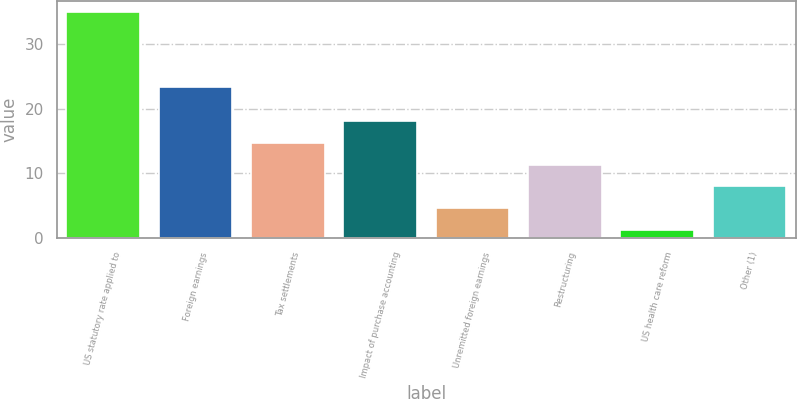Convert chart to OTSL. <chart><loc_0><loc_0><loc_500><loc_500><bar_chart><fcel>US statutory rate applied to<fcel>Foreign earnings<fcel>Tax settlements<fcel>Impact of purchase accounting<fcel>Unremitted foreign earnings<fcel>Restructuring<fcel>US health care reform<fcel>Other (1)<nl><fcel>35<fcel>23.4<fcel>14.72<fcel>18.1<fcel>4.58<fcel>11.34<fcel>1.2<fcel>7.96<nl></chart> 